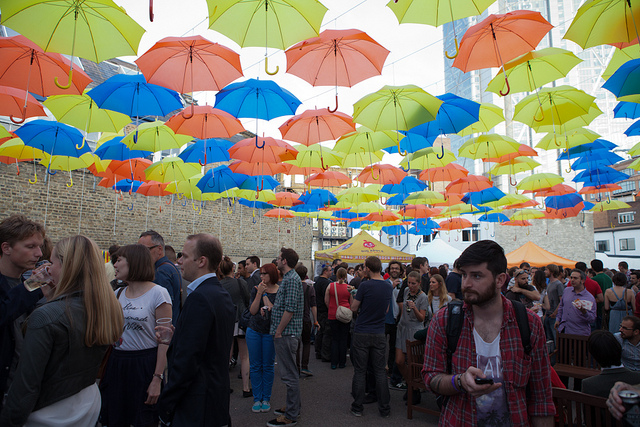Identify and read out the text in this image. A 